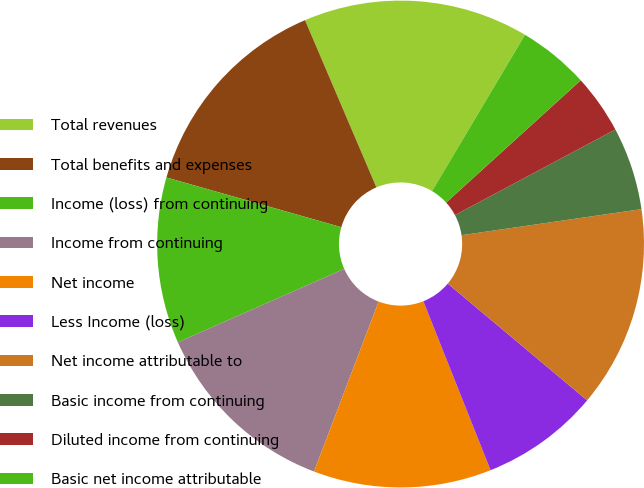<chart> <loc_0><loc_0><loc_500><loc_500><pie_chart><fcel>Total revenues<fcel>Total benefits and expenses<fcel>Income (loss) from continuing<fcel>Income from continuing<fcel>Net income<fcel>Less Income (loss)<fcel>Net income attributable to<fcel>Basic income from continuing<fcel>Diluted income from continuing<fcel>Basic net income attributable<nl><fcel>14.96%<fcel>14.17%<fcel>11.02%<fcel>12.6%<fcel>11.81%<fcel>7.87%<fcel>13.39%<fcel>5.51%<fcel>3.94%<fcel>4.72%<nl></chart> 